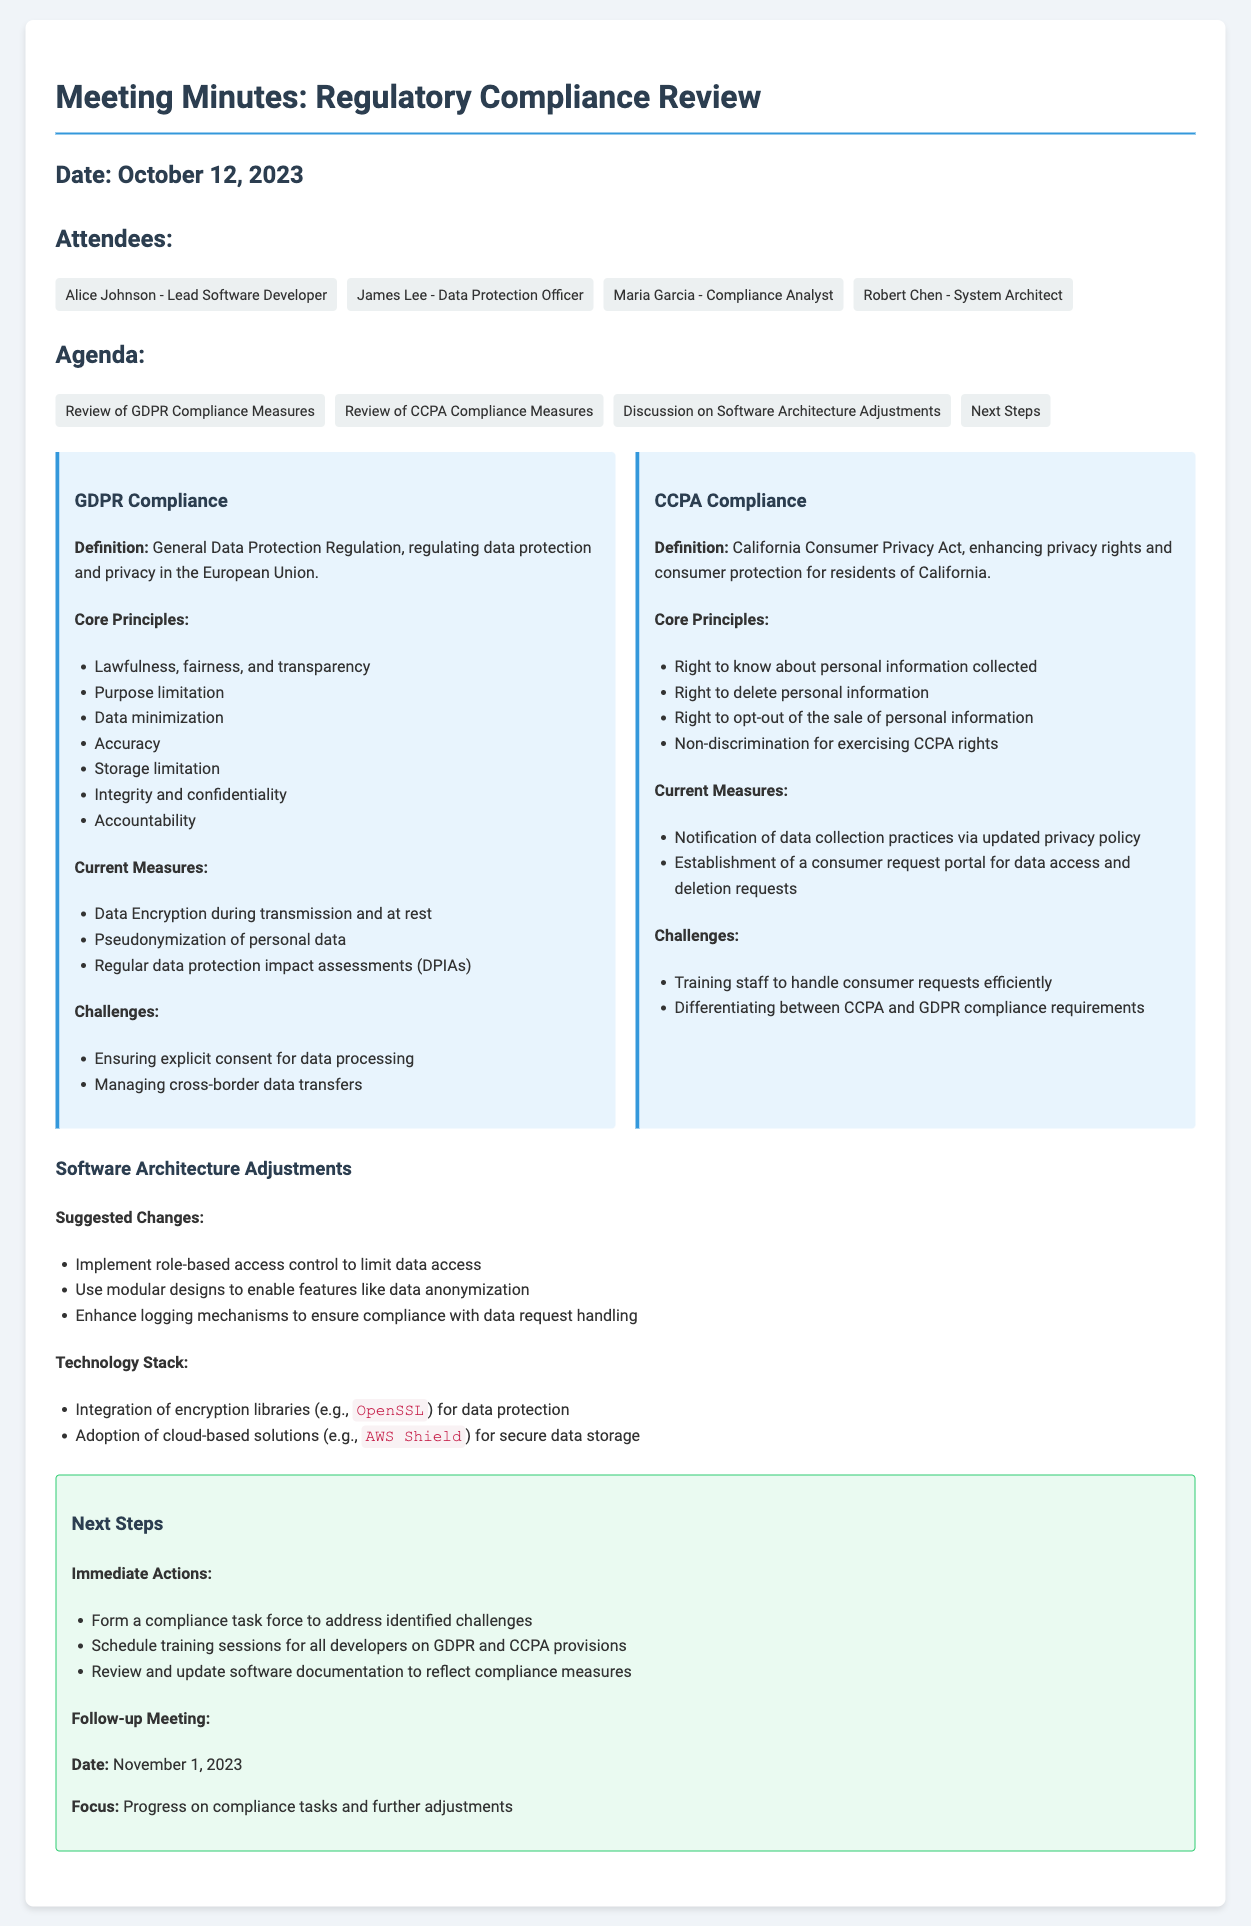What is the date of the meeting? The date of the meeting is explicitly mentioned in the document.
Answer: October 12, 2023 Who is the Data Protection Officer? The document lists the attendees and identifies James Lee as the Data Protection Officer.
Answer: James Lee What are the core principles of GDPR? The document lists the core principles of GDPR under a specific section.
Answer: Lawfulness, fairness, and transparency; Purpose limitation; Data minimization; Accuracy; Storage limitation; Integrity and confidentiality; Accountability What are the current CCPA compliance measures? Current measures for CCPA compliance are detailed in the document.
Answer: Notification of data collection practices via updated privacy policy; Establishment of a consumer request portal for data access and deletion requests What is one suggested change for software architecture? Suggested changes to the software architecture are provided in the document.
Answer: Implement role-based access control to limit data access How many immediate actions are mentioned in the next steps? The document lists immediate actions as part of the next steps.
Answer: Three When is the follow-up meeting scheduled? The follow-up meeting date is indicated in the next steps section of the document.
Answer: November 1, 2023 What is a core challenge related to GDPR? The document outlines specific challenges faced in terms of GDPR compliance.
Answer: Ensuring explicit consent for data processing 